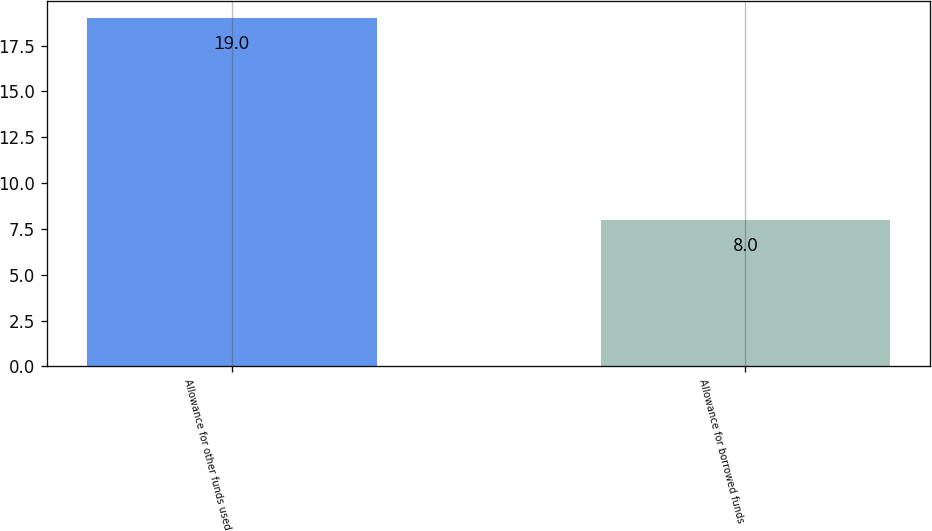<chart> <loc_0><loc_0><loc_500><loc_500><bar_chart><fcel>Allowance for other funds used<fcel>Allowance for borrowed funds<nl><fcel>19<fcel>8<nl></chart> 